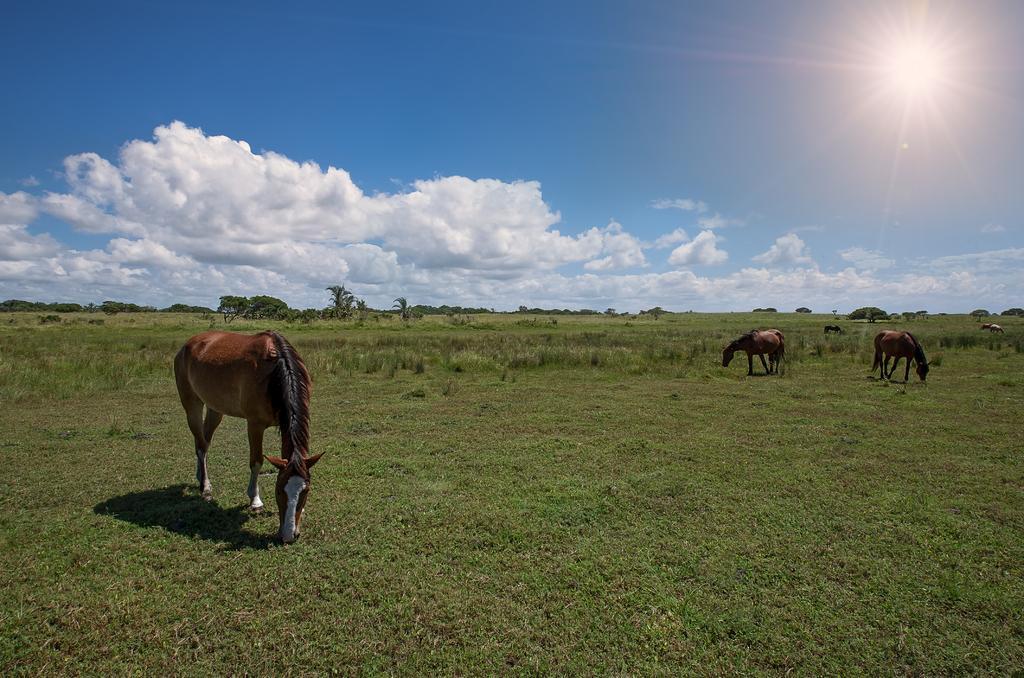Please provide a concise description of this image. In the image we can see there are horses, brown and white in color. Here we can see grass, trees, cloudy sky and the sun. 